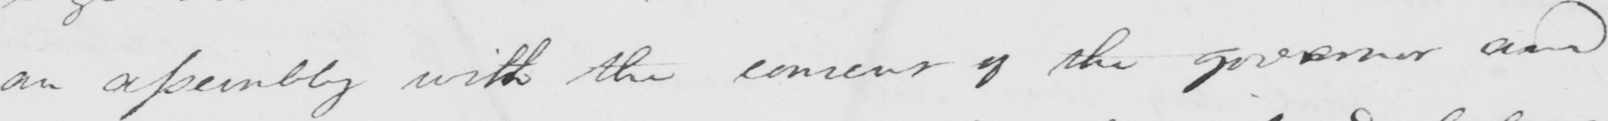What text is written in this handwritten line? an assembly with the consent of the governor and 